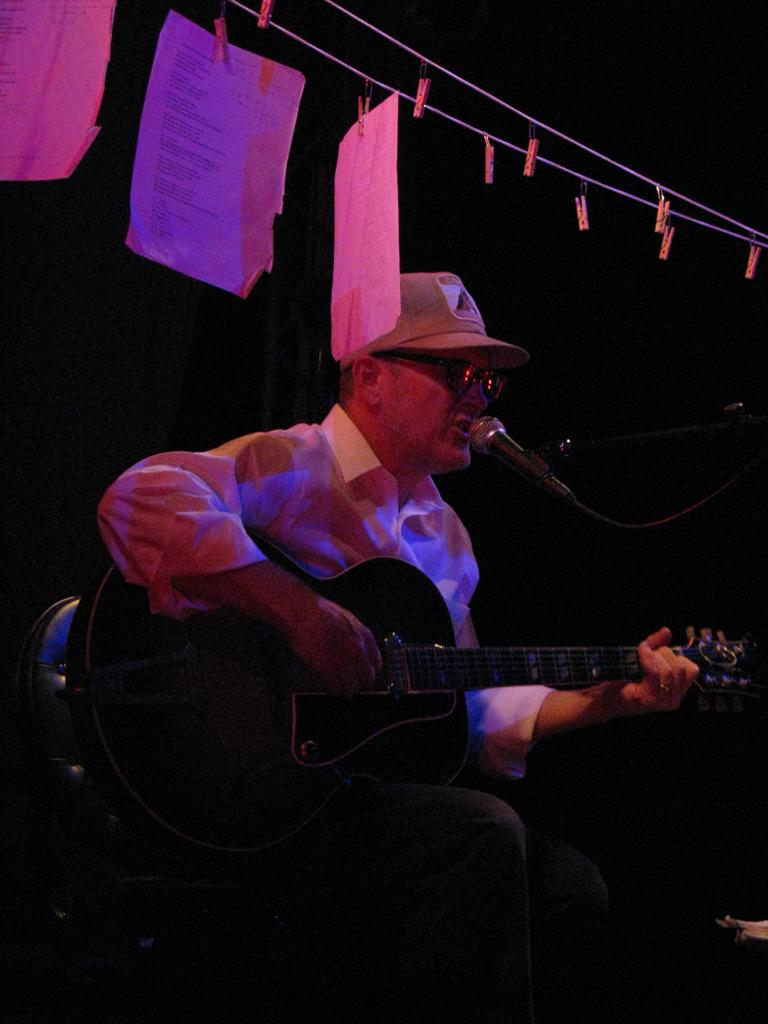What objects can be seen in the image? There are papers and a man holding a guitar in the image. What is the man doing with the guitar? The man is holding a guitar, which suggests he might be playing or about to play it. What is in front of the man? There is a microphone in front of the man. How many toes can be seen on the man's feet in the image? There is no visible indication of the man's feet or toes in the image. 